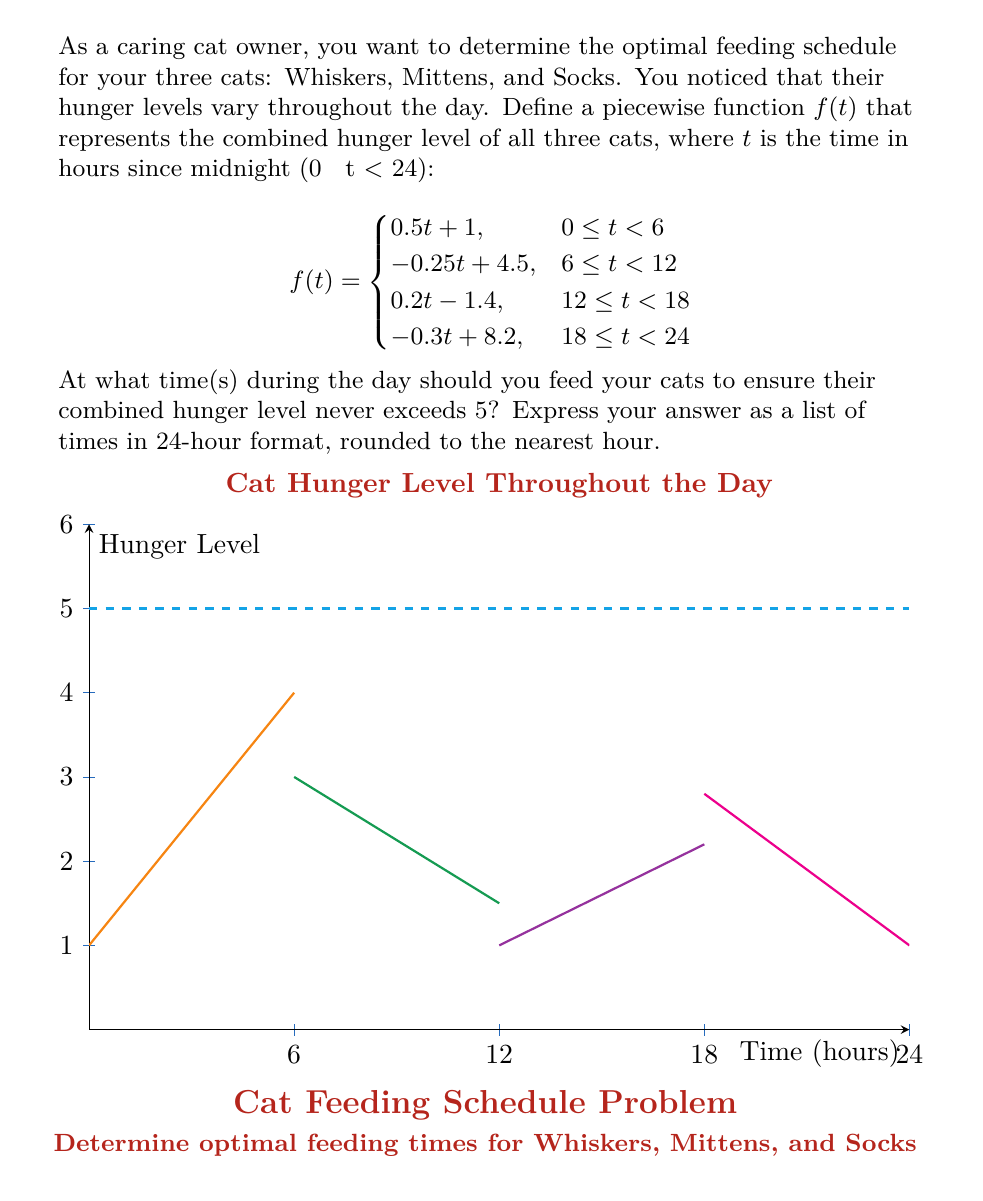Help me with this question. Let's approach this step-by-step:

1) We need to find the times when the hunger level reaches 5, as these will be our feeding times.

2) For $0 \leq t < 6$:
   $0.5t + 1 = 5$
   $0.5t = 4$
   $t = 8$ (This is outside the valid range for this piece)

3) For $6 \leq t < 12$:
   $-0.25t + 4.5 = 5$
   $-0.25t = 0.5$
   $t = -2$ (This is outside the valid range for this piece)

4) For $12 \leq t < 18$:
   $0.2t - 1.4 = 5$
   $0.2t = 6.4$
   $t = 32$ (This is outside the valid range for this piece)

5) For $18 \leq t < 24$:
   $-0.3t + 8.2 = 5$
   $-0.3t = -3.2$
   $t = 10.67$ (This is outside the valid range for this piece)

6) Since we didn't find any solutions within the valid ranges, we need to look at the transition points between pieces:

   At $t = 6$: $f(6) = 0.5(6) + 1 = 4$
   At $t = 12$: $f(12) = -0.25(12) + 4.5 = 1.5$
   At $t = 18$: $f(18) = 0.2(18) - 1.4 = 2.2$
   At $t = 24$ (or $t = 0$): $f(24) = -0.3(24) + 8.2 = 1 = f(0)$

7) The function reaches its maximum values at $t = 6$ and $t = 24$ (or $t = 0$).

8) To keep the hunger level below 5, we should feed the cats just before these peak times, which are at 6:00 and 24:00 (or 0:00).
Answer: 06:00, 24:00 (or 00:00) 